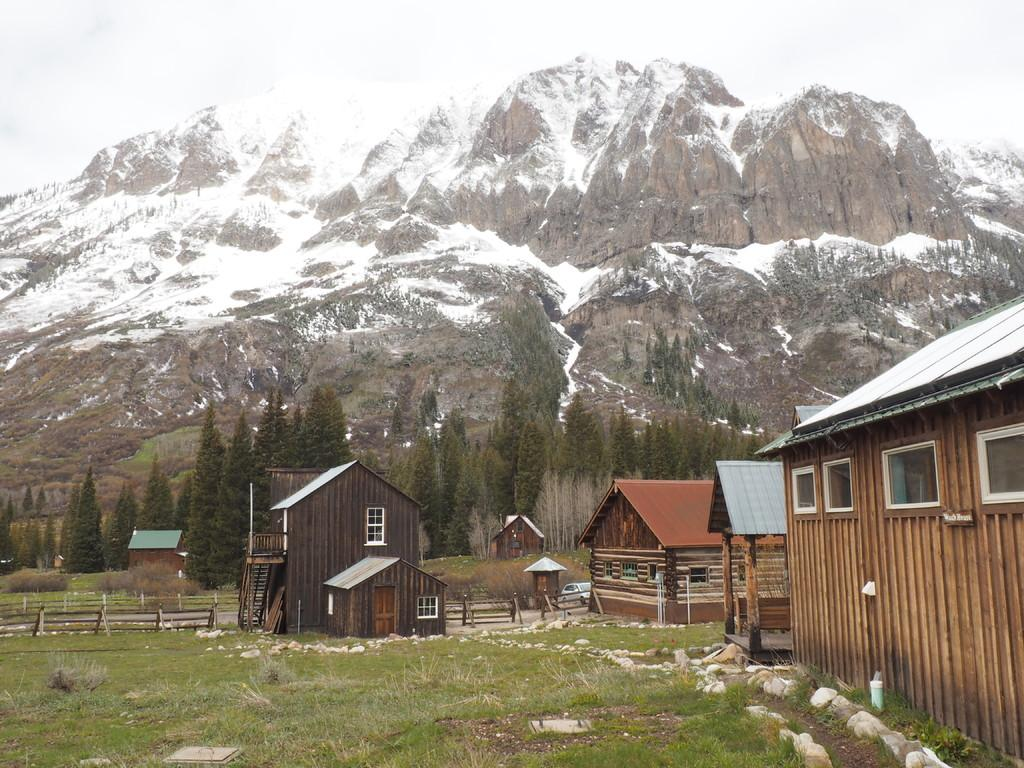What type of houses are in the image? There are wooden houses in the image. What is the landscape surrounding the houses? There is a lot of grass around the houses. What can be seen in the background of the image? There are many trees in the background of the image. What is the most prominent geographical feature in the image? There is a mountain visible behind the trees. How does the love between the two wooden houses manifest in the image? There is no indication of love between the wooden houses in the image, as they are inanimate objects. 